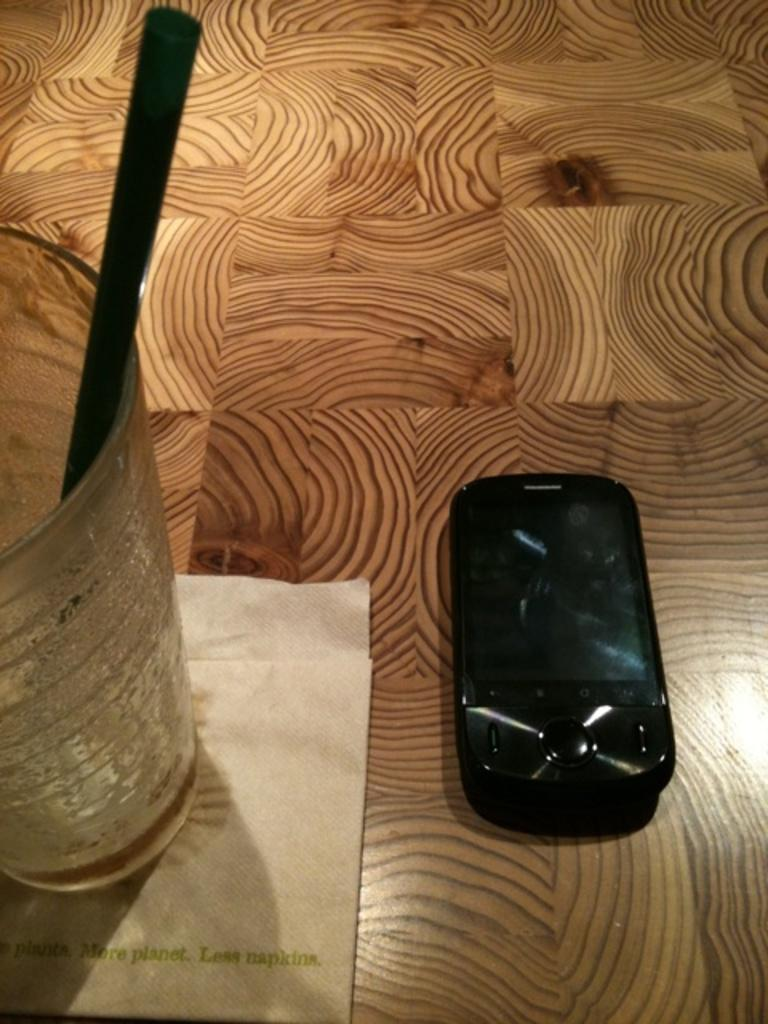<image>
Relay a brief, clear account of the picture shown. A drink sits on a napkin reading more planet, less napkins. 